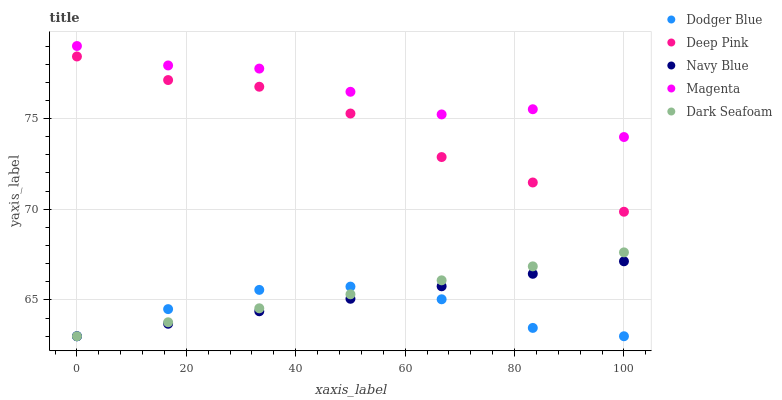Does Dodger Blue have the minimum area under the curve?
Answer yes or no. Yes. Does Magenta have the maximum area under the curve?
Answer yes or no. Yes. Does Deep Pink have the minimum area under the curve?
Answer yes or no. No. Does Deep Pink have the maximum area under the curve?
Answer yes or no. No. Is Navy Blue the smoothest?
Answer yes or no. Yes. Is Magenta the roughest?
Answer yes or no. Yes. Is Deep Pink the smoothest?
Answer yes or no. No. Is Deep Pink the roughest?
Answer yes or no. No. Does Navy Blue have the lowest value?
Answer yes or no. Yes. Does Deep Pink have the lowest value?
Answer yes or no. No. Does Magenta have the highest value?
Answer yes or no. Yes. Does Deep Pink have the highest value?
Answer yes or no. No. Is Navy Blue less than Deep Pink?
Answer yes or no. Yes. Is Magenta greater than Deep Pink?
Answer yes or no. Yes. Does Dodger Blue intersect Navy Blue?
Answer yes or no. Yes. Is Dodger Blue less than Navy Blue?
Answer yes or no. No. Is Dodger Blue greater than Navy Blue?
Answer yes or no. No. Does Navy Blue intersect Deep Pink?
Answer yes or no. No. 